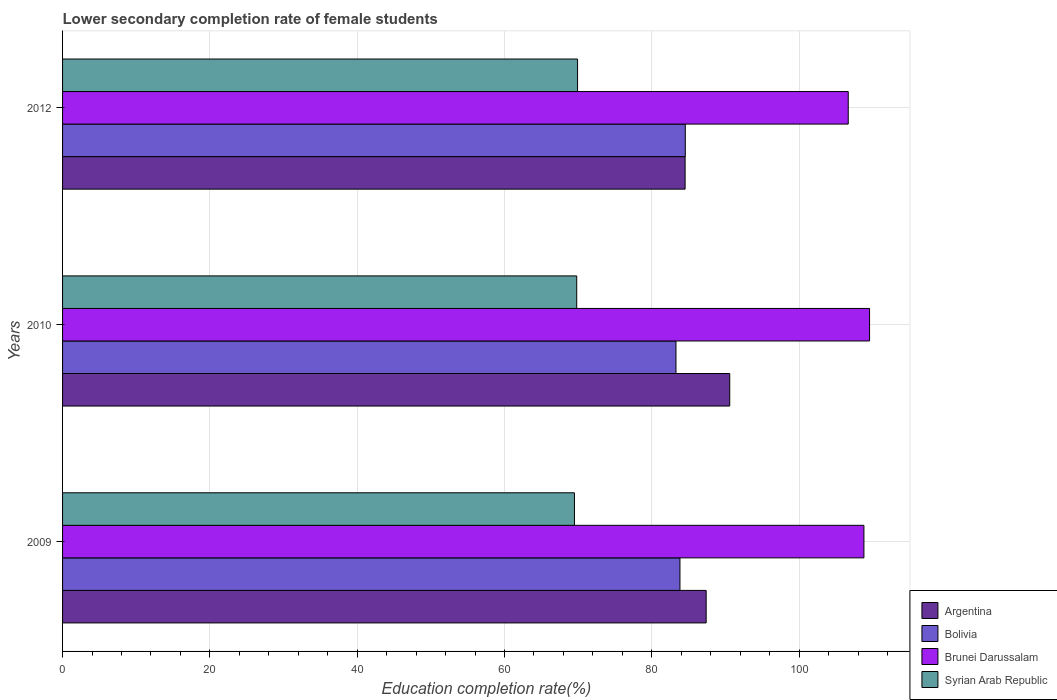How many different coloured bars are there?
Make the answer very short. 4. How many groups of bars are there?
Ensure brevity in your answer.  3. Are the number of bars on each tick of the Y-axis equal?
Offer a very short reply. Yes. How many bars are there on the 2nd tick from the bottom?
Offer a very short reply. 4. In how many cases, is the number of bars for a given year not equal to the number of legend labels?
Offer a terse response. 0. What is the lower secondary completion rate of female students in Bolivia in 2012?
Your response must be concise. 84.55. Across all years, what is the maximum lower secondary completion rate of female students in Argentina?
Give a very brief answer. 90.58. Across all years, what is the minimum lower secondary completion rate of female students in Syrian Arab Republic?
Ensure brevity in your answer.  69.5. In which year was the lower secondary completion rate of female students in Syrian Arab Republic minimum?
Make the answer very short. 2009. What is the total lower secondary completion rate of female students in Argentina in the graph?
Your answer should be very brief. 262.49. What is the difference between the lower secondary completion rate of female students in Argentina in 2010 and that in 2012?
Offer a very short reply. 6.06. What is the difference between the lower secondary completion rate of female students in Bolivia in 2010 and the lower secondary completion rate of female students in Argentina in 2012?
Your response must be concise. -1.24. What is the average lower secondary completion rate of female students in Syrian Arab Republic per year?
Your response must be concise. 69.74. In the year 2010, what is the difference between the lower secondary completion rate of female students in Brunei Darussalam and lower secondary completion rate of female students in Bolivia?
Offer a very short reply. 26.29. What is the ratio of the lower secondary completion rate of female students in Syrian Arab Republic in 2009 to that in 2010?
Ensure brevity in your answer.  1. Is the difference between the lower secondary completion rate of female students in Brunei Darussalam in 2010 and 2012 greater than the difference between the lower secondary completion rate of female students in Bolivia in 2010 and 2012?
Keep it short and to the point. Yes. What is the difference between the highest and the second highest lower secondary completion rate of female students in Bolivia?
Provide a succinct answer. 0.73. What is the difference between the highest and the lowest lower secondary completion rate of female students in Bolivia?
Keep it short and to the point. 1.27. In how many years, is the lower secondary completion rate of female students in Syrian Arab Republic greater than the average lower secondary completion rate of female students in Syrian Arab Republic taken over all years?
Provide a succinct answer. 2. Is the sum of the lower secondary completion rate of female students in Brunei Darussalam in 2010 and 2012 greater than the maximum lower secondary completion rate of female students in Bolivia across all years?
Ensure brevity in your answer.  Yes. What does the 2nd bar from the top in 2010 represents?
Ensure brevity in your answer.  Brunei Darussalam. What does the 2nd bar from the bottom in 2010 represents?
Keep it short and to the point. Bolivia. Is it the case that in every year, the sum of the lower secondary completion rate of female students in Bolivia and lower secondary completion rate of female students in Brunei Darussalam is greater than the lower secondary completion rate of female students in Argentina?
Ensure brevity in your answer.  Yes. How many bars are there?
Your answer should be compact. 12. What is the difference between two consecutive major ticks on the X-axis?
Offer a very short reply. 20. Where does the legend appear in the graph?
Provide a short and direct response. Bottom right. How are the legend labels stacked?
Ensure brevity in your answer.  Vertical. What is the title of the graph?
Make the answer very short. Lower secondary completion rate of female students. Does "Ethiopia" appear as one of the legend labels in the graph?
Give a very brief answer. No. What is the label or title of the X-axis?
Offer a very short reply. Education completion rate(%). What is the label or title of the Y-axis?
Your answer should be compact. Years. What is the Education completion rate(%) of Argentina in 2009?
Make the answer very short. 87.38. What is the Education completion rate(%) in Bolivia in 2009?
Make the answer very short. 83.82. What is the Education completion rate(%) of Brunei Darussalam in 2009?
Provide a succinct answer. 108.8. What is the Education completion rate(%) in Syrian Arab Republic in 2009?
Make the answer very short. 69.5. What is the Education completion rate(%) in Argentina in 2010?
Offer a very short reply. 90.58. What is the Education completion rate(%) in Bolivia in 2010?
Your answer should be very brief. 83.28. What is the Education completion rate(%) in Brunei Darussalam in 2010?
Your response must be concise. 109.57. What is the Education completion rate(%) of Syrian Arab Republic in 2010?
Your answer should be very brief. 69.81. What is the Education completion rate(%) of Argentina in 2012?
Provide a short and direct response. 84.52. What is the Education completion rate(%) in Bolivia in 2012?
Provide a succinct answer. 84.55. What is the Education completion rate(%) in Brunei Darussalam in 2012?
Keep it short and to the point. 106.67. What is the Education completion rate(%) in Syrian Arab Republic in 2012?
Ensure brevity in your answer.  69.92. Across all years, what is the maximum Education completion rate(%) of Argentina?
Provide a short and direct response. 90.58. Across all years, what is the maximum Education completion rate(%) in Bolivia?
Provide a short and direct response. 84.55. Across all years, what is the maximum Education completion rate(%) in Brunei Darussalam?
Give a very brief answer. 109.57. Across all years, what is the maximum Education completion rate(%) of Syrian Arab Republic?
Give a very brief answer. 69.92. Across all years, what is the minimum Education completion rate(%) of Argentina?
Give a very brief answer. 84.52. Across all years, what is the minimum Education completion rate(%) of Bolivia?
Ensure brevity in your answer.  83.28. Across all years, what is the minimum Education completion rate(%) in Brunei Darussalam?
Your response must be concise. 106.67. Across all years, what is the minimum Education completion rate(%) in Syrian Arab Republic?
Offer a terse response. 69.5. What is the total Education completion rate(%) of Argentina in the graph?
Provide a succinct answer. 262.49. What is the total Education completion rate(%) in Bolivia in the graph?
Your answer should be compact. 251.65. What is the total Education completion rate(%) in Brunei Darussalam in the graph?
Give a very brief answer. 325.04. What is the total Education completion rate(%) of Syrian Arab Republic in the graph?
Provide a short and direct response. 209.23. What is the difference between the Education completion rate(%) of Argentina in 2009 and that in 2010?
Keep it short and to the point. -3.2. What is the difference between the Education completion rate(%) in Bolivia in 2009 and that in 2010?
Your answer should be very brief. 0.54. What is the difference between the Education completion rate(%) of Brunei Darussalam in 2009 and that in 2010?
Make the answer very short. -0.77. What is the difference between the Education completion rate(%) of Syrian Arab Republic in 2009 and that in 2010?
Your answer should be very brief. -0.31. What is the difference between the Education completion rate(%) in Argentina in 2009 and that in 2012?
Provide a succinct answer. 2.86. What is the difference between the Education completion rate(%) of Bolivia in 2009 and that in 2012?
Make the answer very short. -0.73. What is the difference between the Education completion rate(%) in Brunei Darussalam in 2009 and that in 2012?
Make the answer very short. 2.13. What is the difference between the Education completion rate(%) of Syrian Arab Republic in 2009 and that in 2012?
Provide a short and direct response. -0.42. What is the difference between the Education completion rate(%) of Argentina in 2010 and that in 2012?
Offer a very short reply. 6.06. What is the difference between the Education completion rate(%) in Bolivia in 2010 and that in 2012?
Provide a succinct answer. -1.27. What is the difference between the Education completion rate(%) in Brunei Darussalam in 2010 and that in 2012?
Give a very brief answer. 2.9. What is the difference between the Education completion rate(%) of Syrian Arab Republic in 2010 and that in 2012?
Give a very brief answer. -0.11. What is the difference between the Education completion rate(%) of Argentina in 2009 and the Education completion rate(%) of Bolivia in 2010?
Keep it short and to the point. 4.1. What is the difference between the Education completion rate(%) of Argentina in 2009 and the Education completion rate(%) of Brunei Darussalam in 2010?
Your answer should be very brief. -22.18. What is the difference between the Education completion rate(%) in Argentina in 2009 and the Education completion rate(%) in Syrian Arab Republic in 2010?
Your answer should be compact. 17.58. What is the difference between the Education completion rate(%) in Bolivia in 2009 and the Education completion rate(%) in Brunei Darussalam in 2010?
Your answer should be very brief. -25.74. What is the difference between the Education completion rate(%) in Bolivia in 2009 and the Education completion rate(%) in Syrian Arab Republic in 2010?
Provide a short and direct response. 14.02. What is the difference between the Education completion rate(%) in Brunei Darussalam in 2009 and the Education completion rate(%) in Syrian Arab Republic in 2010?
Give a very brief answer. 38.99. What is the difference between the Education completion rate(%) in Argentina in 2009 and the Education completion rate(%) in Bolivia in 2012?
Offer a very short reply. 2.83. What is the difference between the Education completion rate(%) in Argentina in 2009 and the Education completion rate(%) in Brunei Darussalam in 2012?
Offer a very short reply. -19.29. What is the difference between the Education completion rate(%) in Argentina in 2009 and the Education completion rate(%) in Syrian Arab Republic in 2012?
Provide a succinct answer. 17.46. What is the difference between the Education completion rate(%) of Bolivia in 2009 and the Education completion rate(%) of Brunei Darussalam in 2012?
Provide a short and direct response. -22.85. What is the difference between the Education completion rate(%) of Bolivia in 2009 and the Education completion rate(%) of Syrian Arab Republic in 2012?
Offer a very short reply. 13.9. What is the difference between the Education completion rate(%) of Brunei Darussalam in 2009 and the Education completion rate(%) of Syrian Arab Republic in 2012?
Your response must be concise. 38.88. What is the difference between the Education completion rate(%) in Argentina in 2010 and the Education completion rate(%) in Bolivia in 2012?
Your answer should be compact. 6.03. What is the difference between the Education completion rate(%) in Argentina in 2010 and the Education completion rate(%) in Brunei Darussalam in 2012?
Your response must be concise. -16.09. What is the difference between the Education completion rate(%) in Argentina in 2010 and the Education completion rate(%) in Syrian Arab Republic in 2012?
Ensure brevity in your answer.  20.66. What is the difference between the Education completion rate(%) of Bolivia in 2010 and the Education completion rate(%) of Brunei Darussalam in 2012?
Ensure brevity in your answer.  -23.39. What is the difference between the Education completion rate(%) in Bolivia in 2010 and the Education completion rate(%) in Syrian Arab Republic in 2012?
Offer a terse response. 13.36. What is the difference between the Education completion rate(%) of Brunei Darussalam in 2010 and the Education completion rate(%) of Syrian Arab Republic in 2012?
Provide a succinct answer. 39.65. What is the average Education completion rate(%) in Argentina per year?
Give a very brief answer. 87.5. What is the average Education completion rate(%) in Bolivia per year?
Your answer should be compact. 83.88. What is the average Education completion rate(%) in Brunei Darussalam per year?
Your answer should be very brief. 108.35. What is the average Education completion rate(%) of Syrian Arab Republic per year?
Provide a short and direct response. 69.74. In the year 2009, what is the difference between the Education completion rate(%) of Argentina and Education completion rate(%) of Bolivia?
Provide a succinct answer. 3.56. In the year 2009, what is the difference between the Education completion rate(%) in Argentina and Education completion rate(%) in Brunei Darussalam?
Ensure brevity in your answer.  -21.42. In the year 2009, what is the difference between the Education completion rate(%) in Argentina and Education completion rate(%) in Syrian Arab Republic?
Give a very brief answer. 17.88. In the year 2009, what is the difference between the Education completion rate(%) of Bolivia and Education completion rate(%) of Brunei Darussalam?
Your answer should be very brief. -24.98. In the year 2009, what is the difference between the Education completion rate(%) in Bolivia and Education completion rate(%) in Syrian Arab Republic?
Your answer should be compact. 14.32. In the year 2009, what is the difference between the Education completion rate(%) in Brunei Darussalam and Education completion rate(%) in Syrian Arab Republic?
Provide a short and direct response. 39.3. In the year 2010, what is the difference between the Education completion rate(%) of Argentina and Education completion rate(%) of Bolivia?
Your answer should be very brief. 7.3. In the year 2010, what is the difference between the Education completion rate(%) in Argentina and Education completion rate(%) in Brunei Darussalam?
Provide a short and direct response. -18.98. In the year 2010, what is the difference between the Education completion rate(%) of Argentina and Education completion rate(%) of Syrian Arab Republic?
Your answer should be compact. 20.78. In the year 2010, what is the difference between the Education completion rate(%) of Bolivia and Education completion rate(%) of Brunei Darussalam?
Offer a terse response. -26.29. In the year 2010, what is the difference between the Education completion rate(%) in Bolivia and Education completion rate(%) in Syrian Arab Republic?
Provide a succinct answer. 13.47. In the year 2010, what is the difference between the Education completion rate(%) in Brunei Darussalam and Education completion rate(%) in Syrian Arab Republic?
Your answer should be compact. 39.76. In the year 2012, what is the difference between the Education completion rate(%) in Argentina and Education completion rate(%) in Bolivia?
Offer a very short reply. -0.03. In the year 2012, what is the difference between the Education completion rate(%) in Argentina and Education completion rate(%) in Brunei Darussalam?
Provide a succinct answer. -22.15. In the year 2012, what is the difference between the Education completion rate(%) in Argentina and Education completion rate(%) in Syrian Arab Republic?
Offer a very short reply. 14.6. In the year 2012, what is the difference between the Education completion rate(%) in Bolivia and Education completion rate(%) in Brunei Darussalam?
Provide a short and direct response. -22.12. In the year 2012, what is the difference between the Education completion rate(%) in Bolivia and Education completion rate(%) in Syrian Arab Republic?
Your answer should be compact. 14.63. In the year 2012, what is the difference between the Education completion rate(%) in Brunei Darussalam and Education completion rate(%) in Syrian Arab Republic?
Your answer should be very brief. 36.75. What is the ratio of the Education completion rate(%) in Argentina in 2009 to that in 2010?
Keep it short and to the point. 0.96. What is the ratio of the Education completion rate(%) in Brunei Darussalam in 2009 to that in 2010?
Your answer should be compact. 0.99. What is the ratio of the Education completion rate(%) in Syrian Arab Republic in 2009 to that in 2010?
Your answer should be very brief. 1. What is the ratio of the Education completion rate(%) of Argentina in 2009 to that in 2012?
Ensure brevity in your answer.  1.03. What is the ratio of the Education completion rate(%) in Bolivia in 2009 to that in 2012?
Give a very brief answer. 0.99. What is the ratio of the Education completion rate(%) in Brunei Darussalam in 2009 to that in 2012?
Provide a succinct answer. 1.02. What is the ratio of the Education completion rate(%) of Syrian Arab Republic in 2009 to that in 2012?
Ensure brevity in your answer.  0.99. What is the ratio of the Education completion rate(%) in Argentina in 2010 to that in 2012?
Offer a very short reply. 1.07. What is the ratio of the Education completion rate(%) in Brunei Darussalam in 2010 to that in 2012?
Ensure brevity in your answer.  1.03. What is the difference between the highest and the second highest Education completion rate(%) of Argentina?
Your answer should be very brief. 3.2. What is the difference between the highest and the second highest Education completion rate(%) of Bolivia?
Your response must be concise. 0.73. What is the difference between the highest and the second highest Education completion rate(%) of Brunei Darussalam?
Provide a succinct answer. 0.77. What is the difference between the highest and the second highest Education completion rate(%) of Syrian Arab Republic?
Provide a succinct answer. 0.11. What is the difference between the highest and the lowest Education completion rate(%) in Argentina?
Keep it short and to the point. 6.06. What is the difference between the highest and the lowest Education completion rate(%) of Bolivia?
Offer a very short reply. 1.27. What is the difference between the highest and the lowest Education completion rate(%) of Brunei Darussalam?
Your answer should be very brief. 2.9. What is the difference between the highest and the lowest Education completion rate(%) in Syrian Arab Republic?
Ensure brevity in your answer.  0.42. 